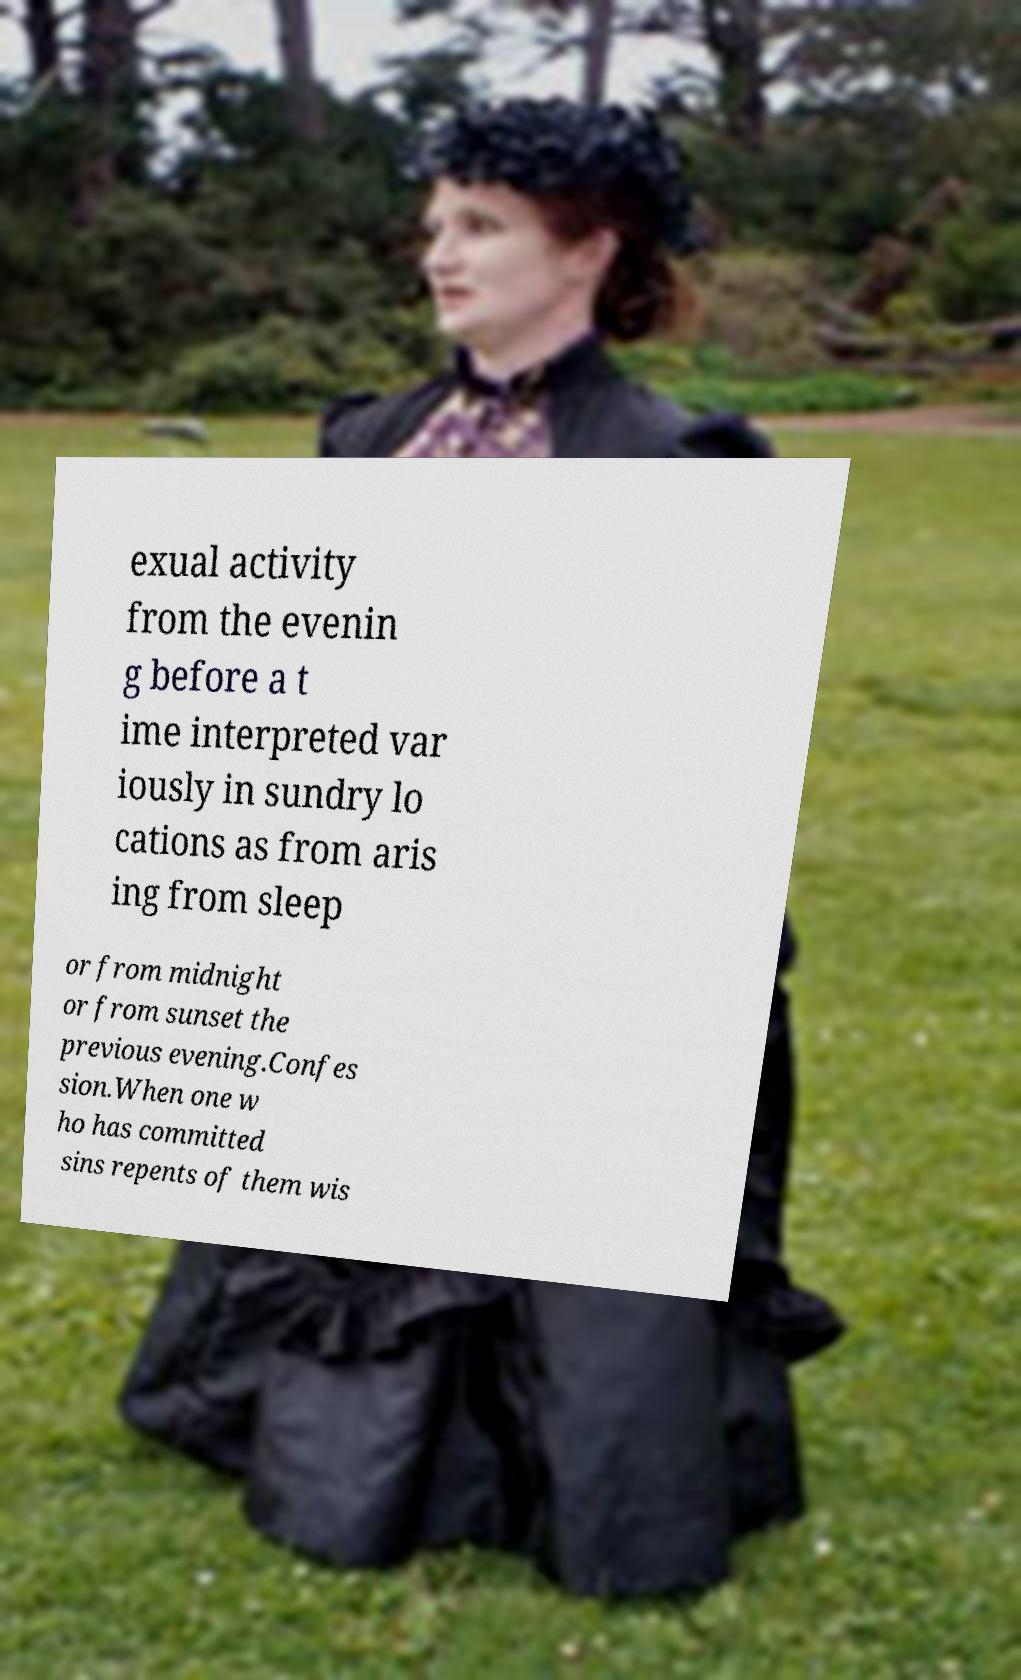Could you assist in decoding the text presented in this image and type it out clearly? exual activity from the evenin g before a t ime interpreted var iously in sundry lo cations as from aris ing from sleep or from midnight or from sunset the previous evening.Confes sion.When one w ho has committed sins repents of them wis 